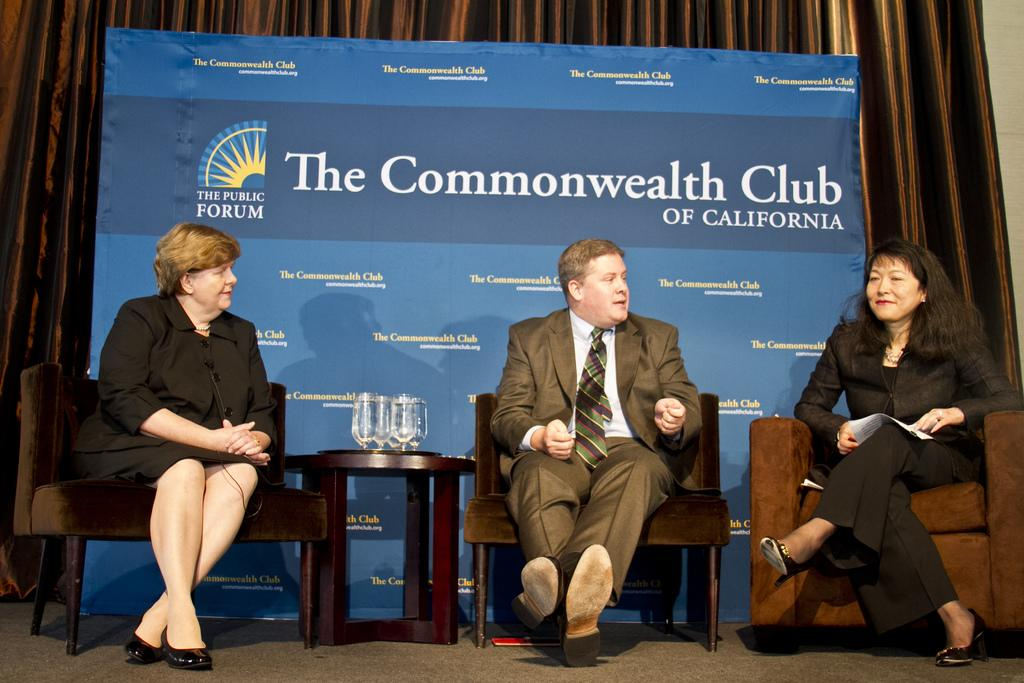What is the person in the image doing? There is a person sitting on a chair in the image. What objects are on the table in the image? There are glass tumblers on a table in the image. What can be seen in the background of the image? There is an advertisement, a curtain, and a wall in the background of the image. What type of degree does the person in the image have? There is no information about the person's education or degree in the image. 